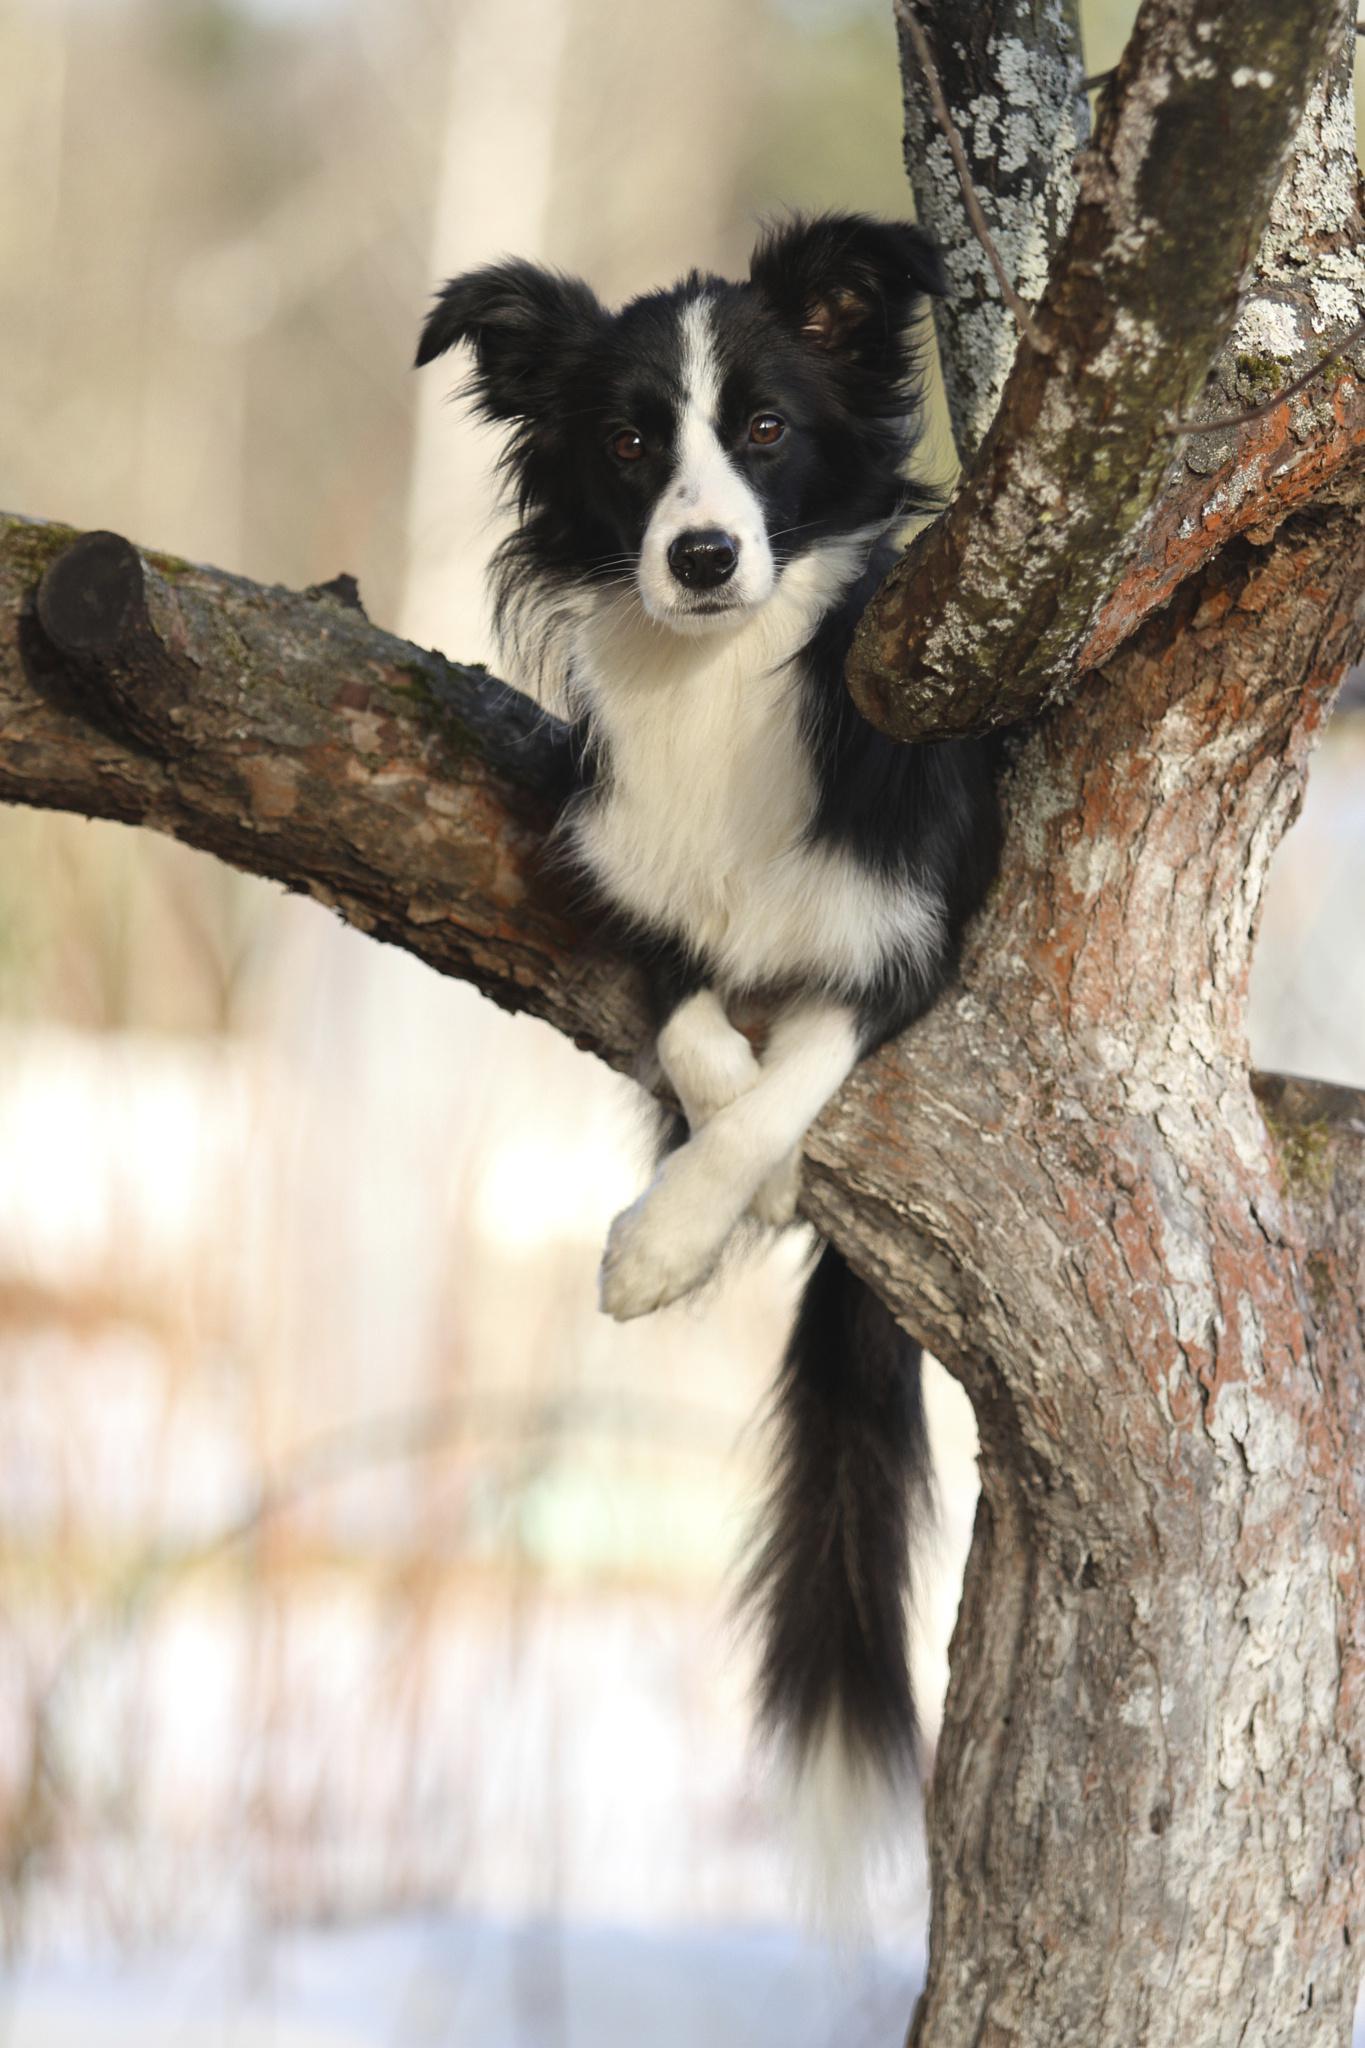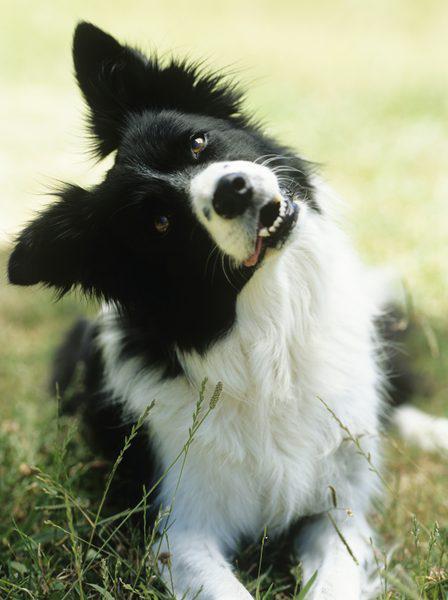The first image is the image on the left, the second image is the image on the right. Given the left and right images, does the statement "In one image, a black and white dog is outdoors with sheep." hold true? Answer yes or no. No. The first image is the image on the left, the second image is the image on the right. Assess this claim about the two images: "Right image contains one dog sitting up.". Correct or not? Answer yes or no. No. 